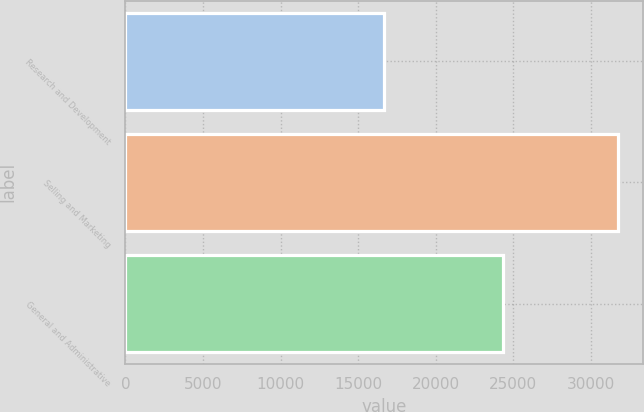Convert chart. <chart><loc_0><loc_0><loc_500><loc_500><bar_chart><fcel>Research and Development<fcel>Selling and Marketing<fcel>General and Administrative<nl><fcel>16659<fcel>31761<fcel>24363<nl></chart> 